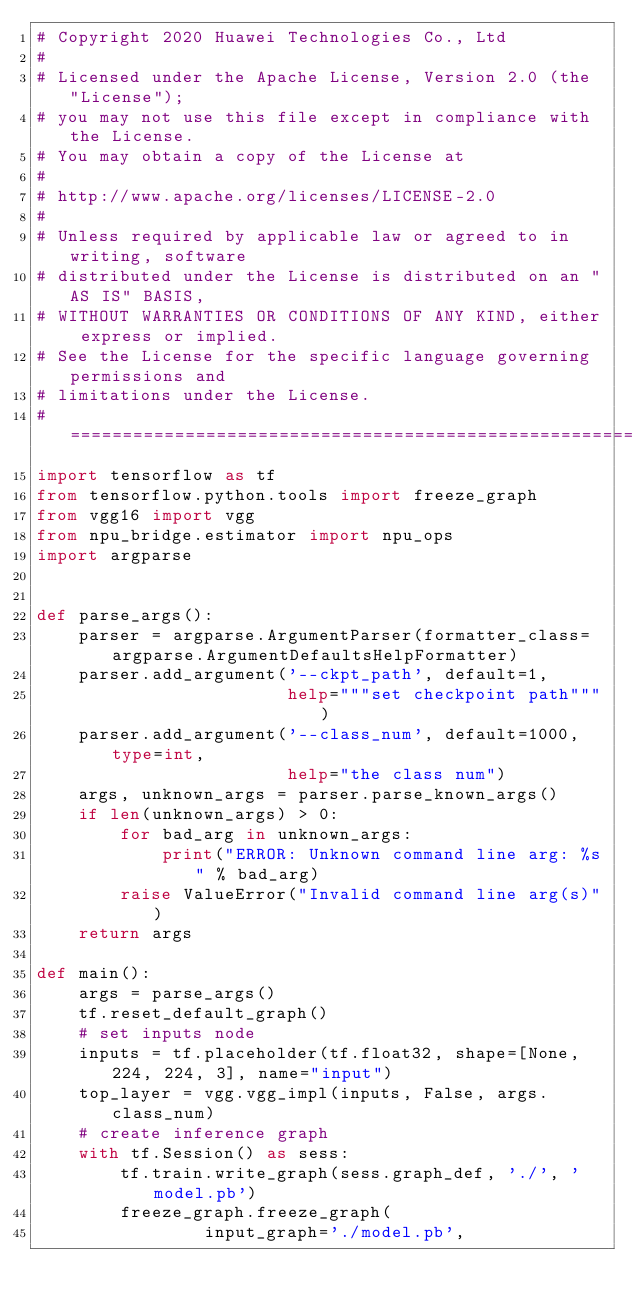Convert code to text. <code><loc_0><loc_0><loc_500><loc_500><_Python_># Copyright 2020 Huawei Technologies Co., Ltd
#
# Licensed under the Apache License, Version 2.0 (the "License");
# you may not use this file except in compliance with the License.
# You may obtain a copy of the License at
#
# http://www.apache.org/licenses/LICENSE-2.0
#
# Unless required by applicable law or agreed to in writing, software
# distributed under the License is distributed on an "AS IS" BASIS,
# WITHOUT WARRANTIES OR CONDITIONS OF ANY KIND, either express or implied.
# See the License for the specific language governing permissions and
# limitations under the License.
# ============================================================================
import tensorflow as tf
from tensorflow.python.tools import freeze_graph
from vgg16 import vgg
from npu_bridge.estimator import npu_ops
import argparse


def parse_args():
    parser = argparse.ArgumentParser(formatter_class=argparse.ArgumentDefaultsHelpFormatter)
    parser.add_argument('--ckpt_path', default=1,
                        help="""set checkpoint path""")
    parser.add_argument('--class_num', default=1000, type=int,
                        help="the class num")
    args, unknown_args = parser.parse_known_args()
    if len(unknown_args) > 0:
        for bad_arg in unknown_args:
            print("ERROR: Unknown command line arg: %s" % bad_arg)
        raise ValueError("Invalid command line arg(s)")
    return args

def main():
    args = parse_args()
    tf.reset_default_graph()
    # set inputs node
    inputs = tf.placeholder(tf.float32, shape=[None, 224, 224, 3], name="input")
    top_layer = vgg.vgg_impl(inputs, False, args.class_num)
    # create inference graph
    with tf.Session() as sess:
        tf.train.write_graph(sess.graph_def, './', 'model.pb')
        freeze_graph.freeze_graph(
		        input_graph='./model.pb',</code> 